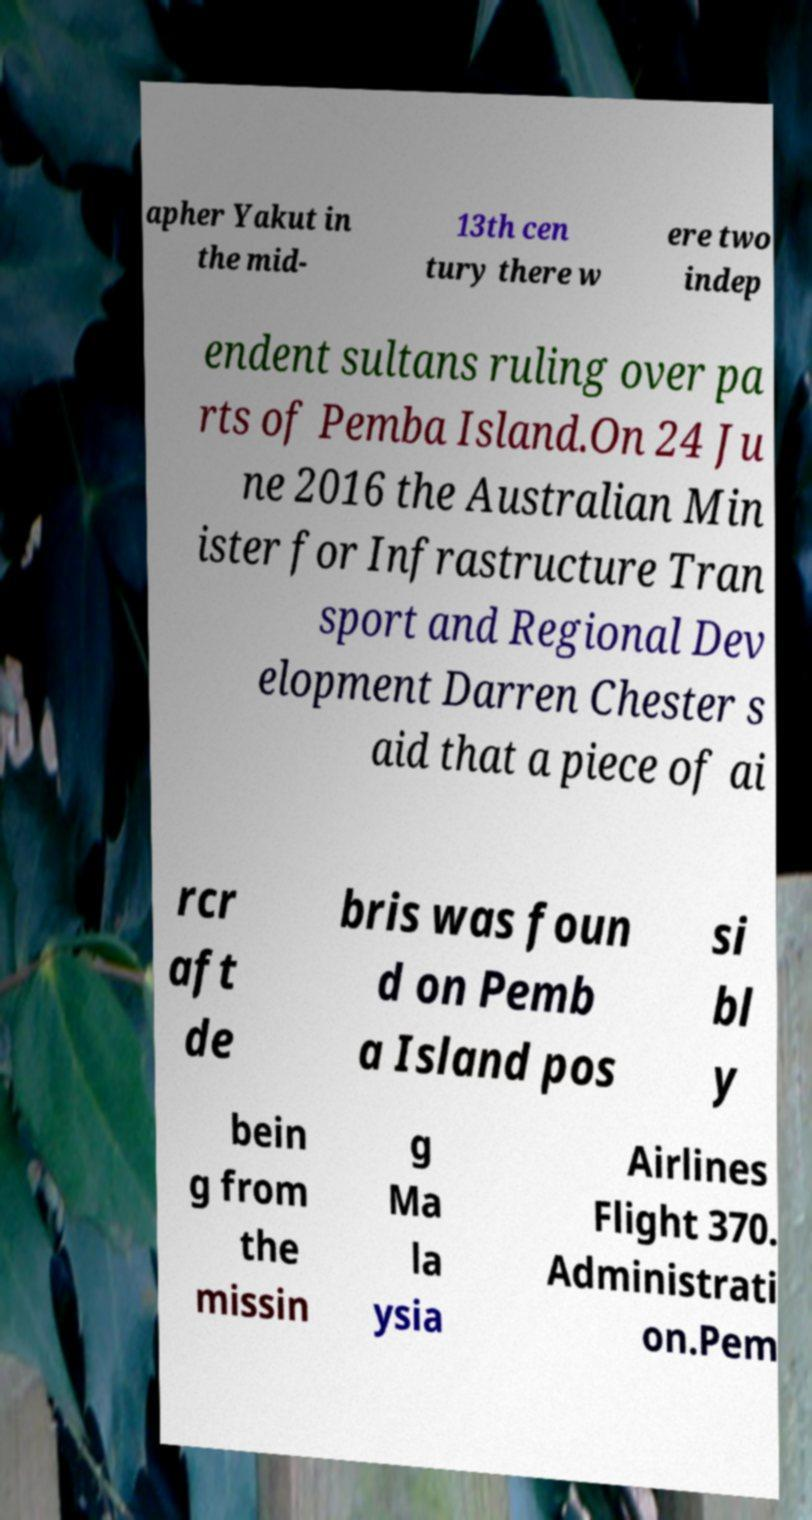What messages or text are displayed in this image? I need them in a readable, typed format. apher Yakut in the mid- 13th cen tury there w ere two indep endent sultans ruling over pa rts of Pemba Island.On 24 Ju ne 2016 the Australian Min ister for Infrastructure Tran sport and Regional Dev elopment Darren Chester s aid that a piece of ai rcr aft de bris was foun d on Pemb a Island pos si bl y bein g from the missin g Ma la ysia Airlines Flight 370. Administrati on.Pem 